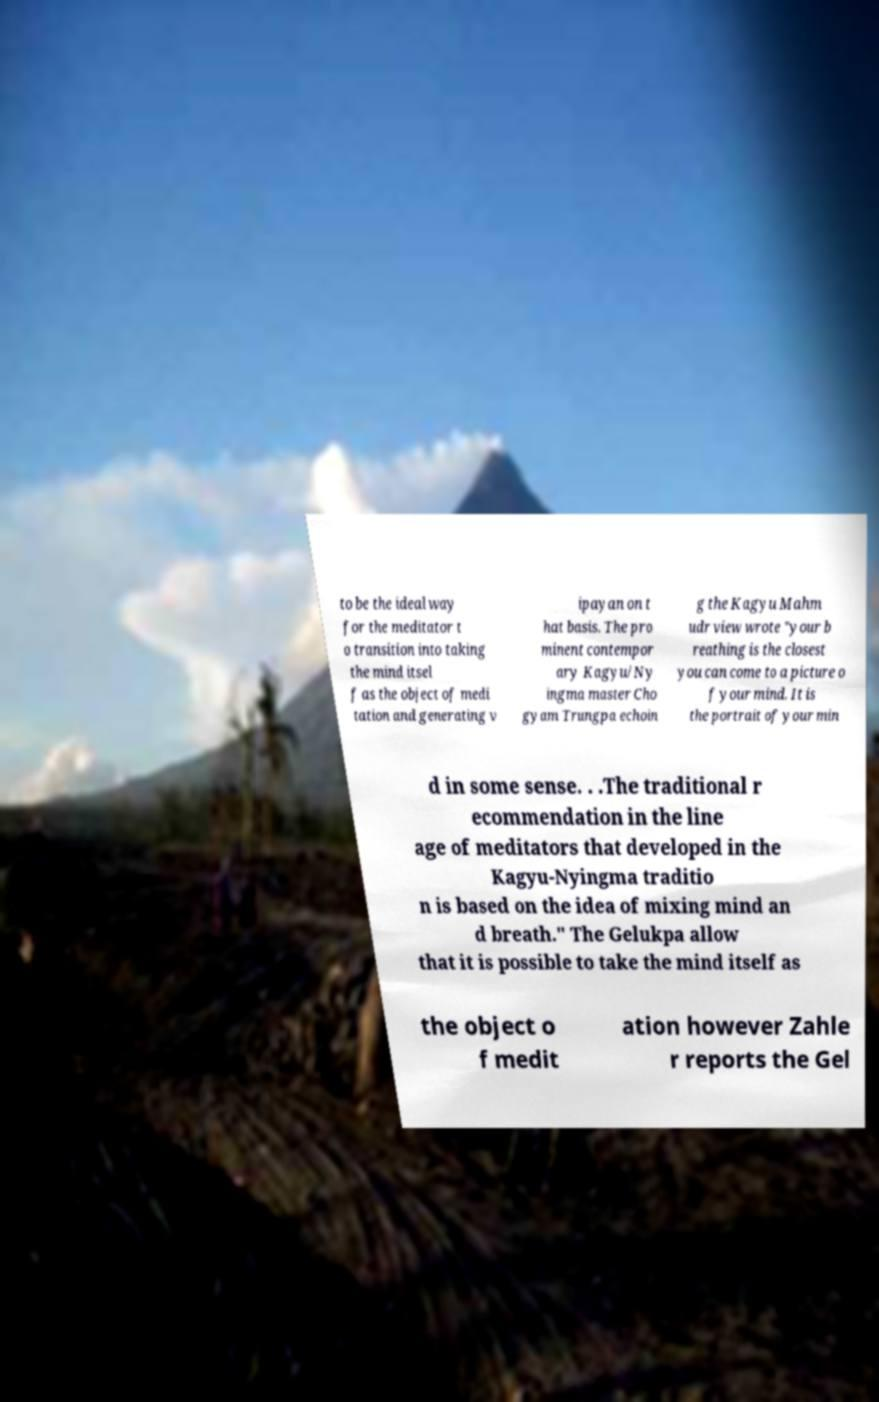Could you extract and type out the text from this image? to be the ideal way for the meditator t o transition into taking the mind itsel f as the object of medi tation and generating v ipayan on t hat basis. The pro minent contempor ary Kagyu/Ny ingma master Cho gyam Trungpa echoin g the Kagyu Mahm udr view wrote "your b reathing is the closest you can come to a picture o f your mind. It is the portrait of your min d in some sense. . .The traditional r ecommendation in the line age of meditators that developed in the Kagyu-Nyingma traditio n is based on the idea of mixing mind an d breath." The Gelukpa allow that it is possible to take the mind itself as the object o f medit ation however Zahle r reports the Gel 